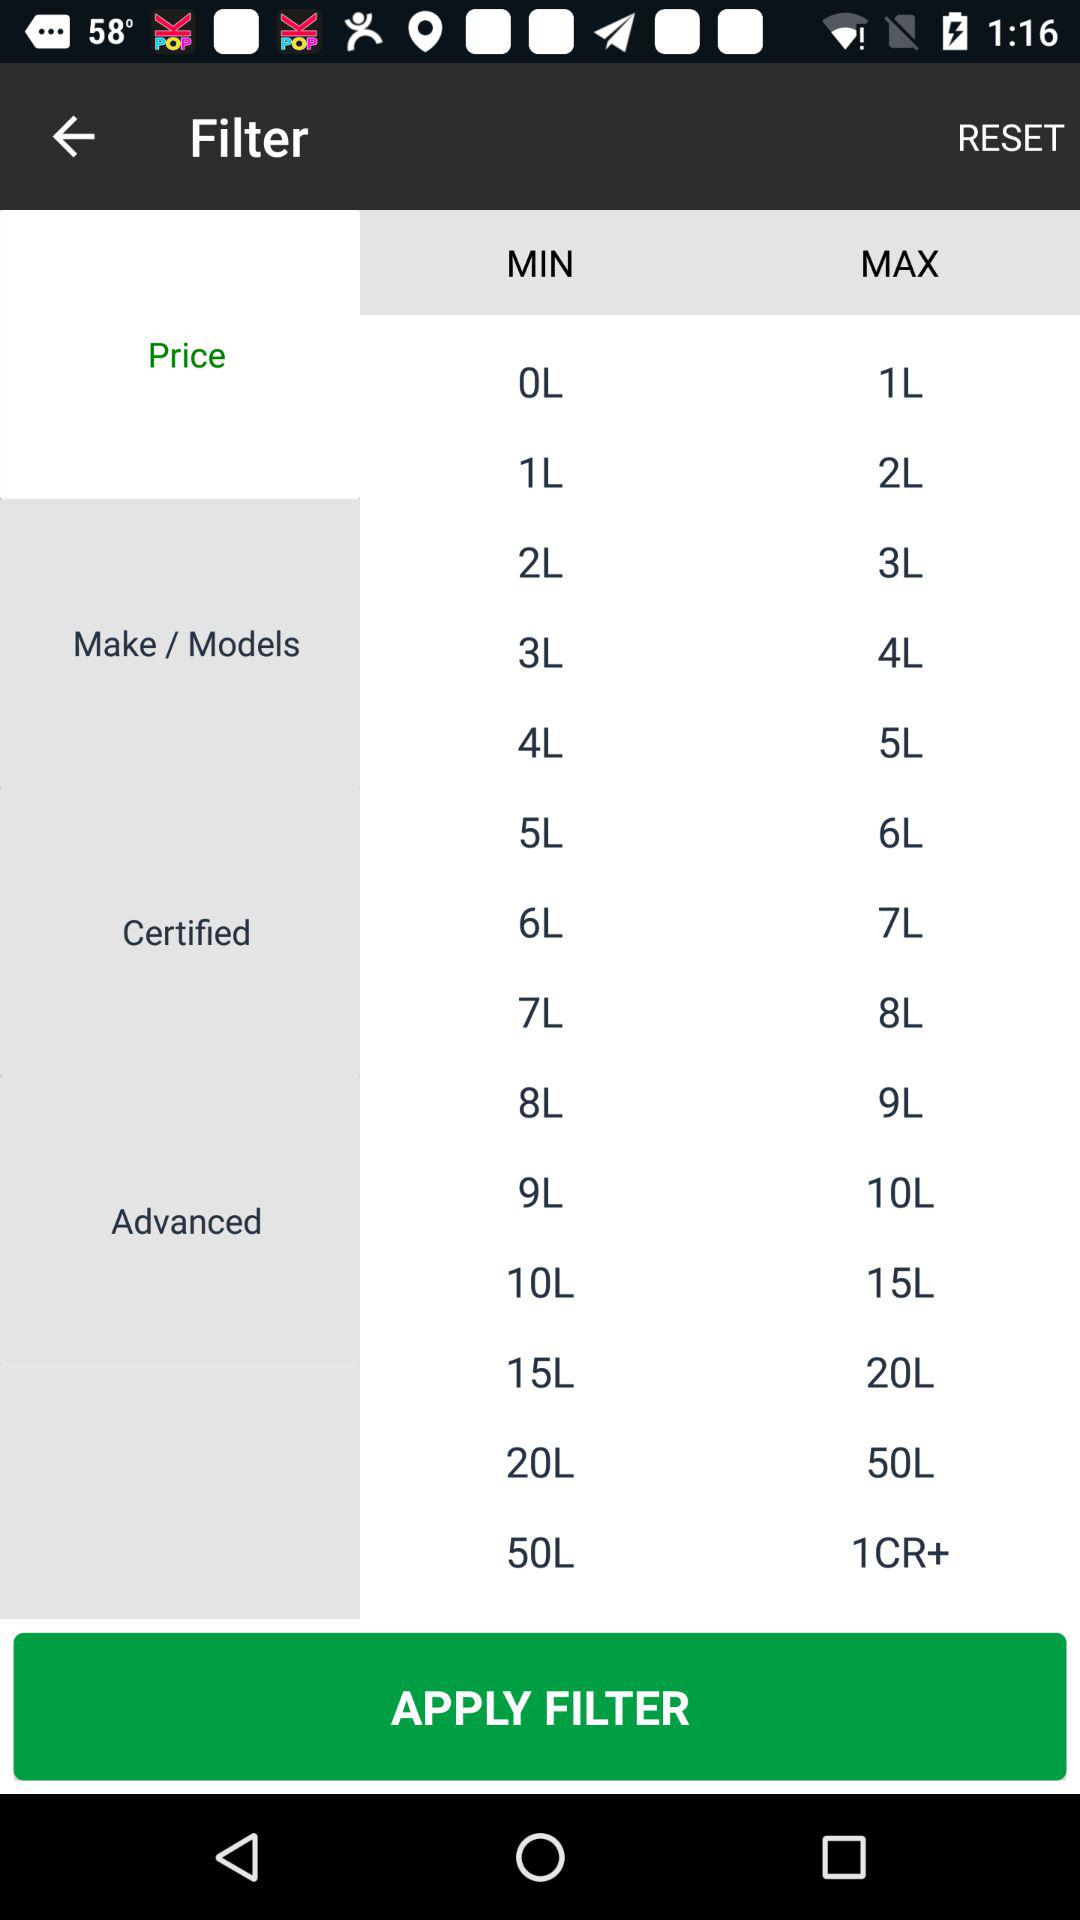How many items are in the make/models section?
Answer the question using a single word or phrase. 6 